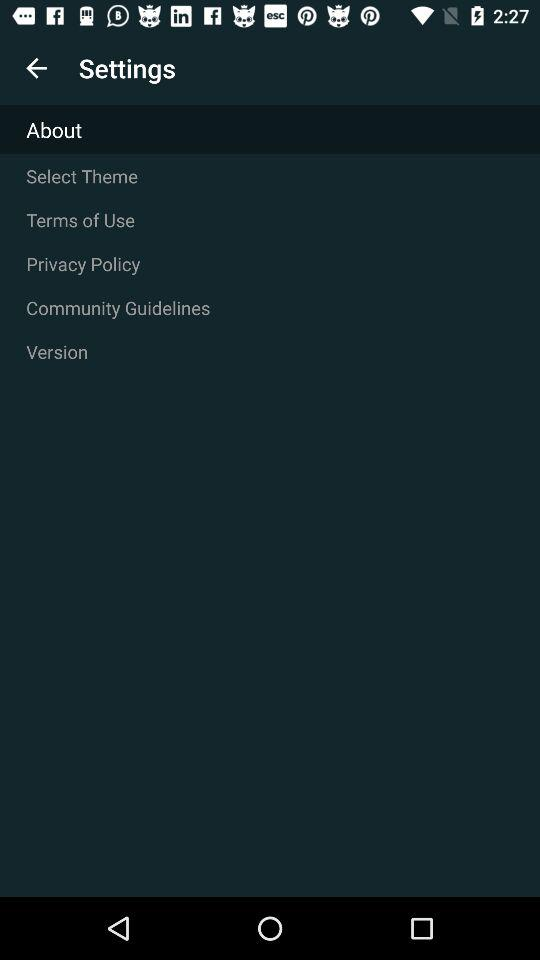What's the selected setting? The selected setting is "About". 